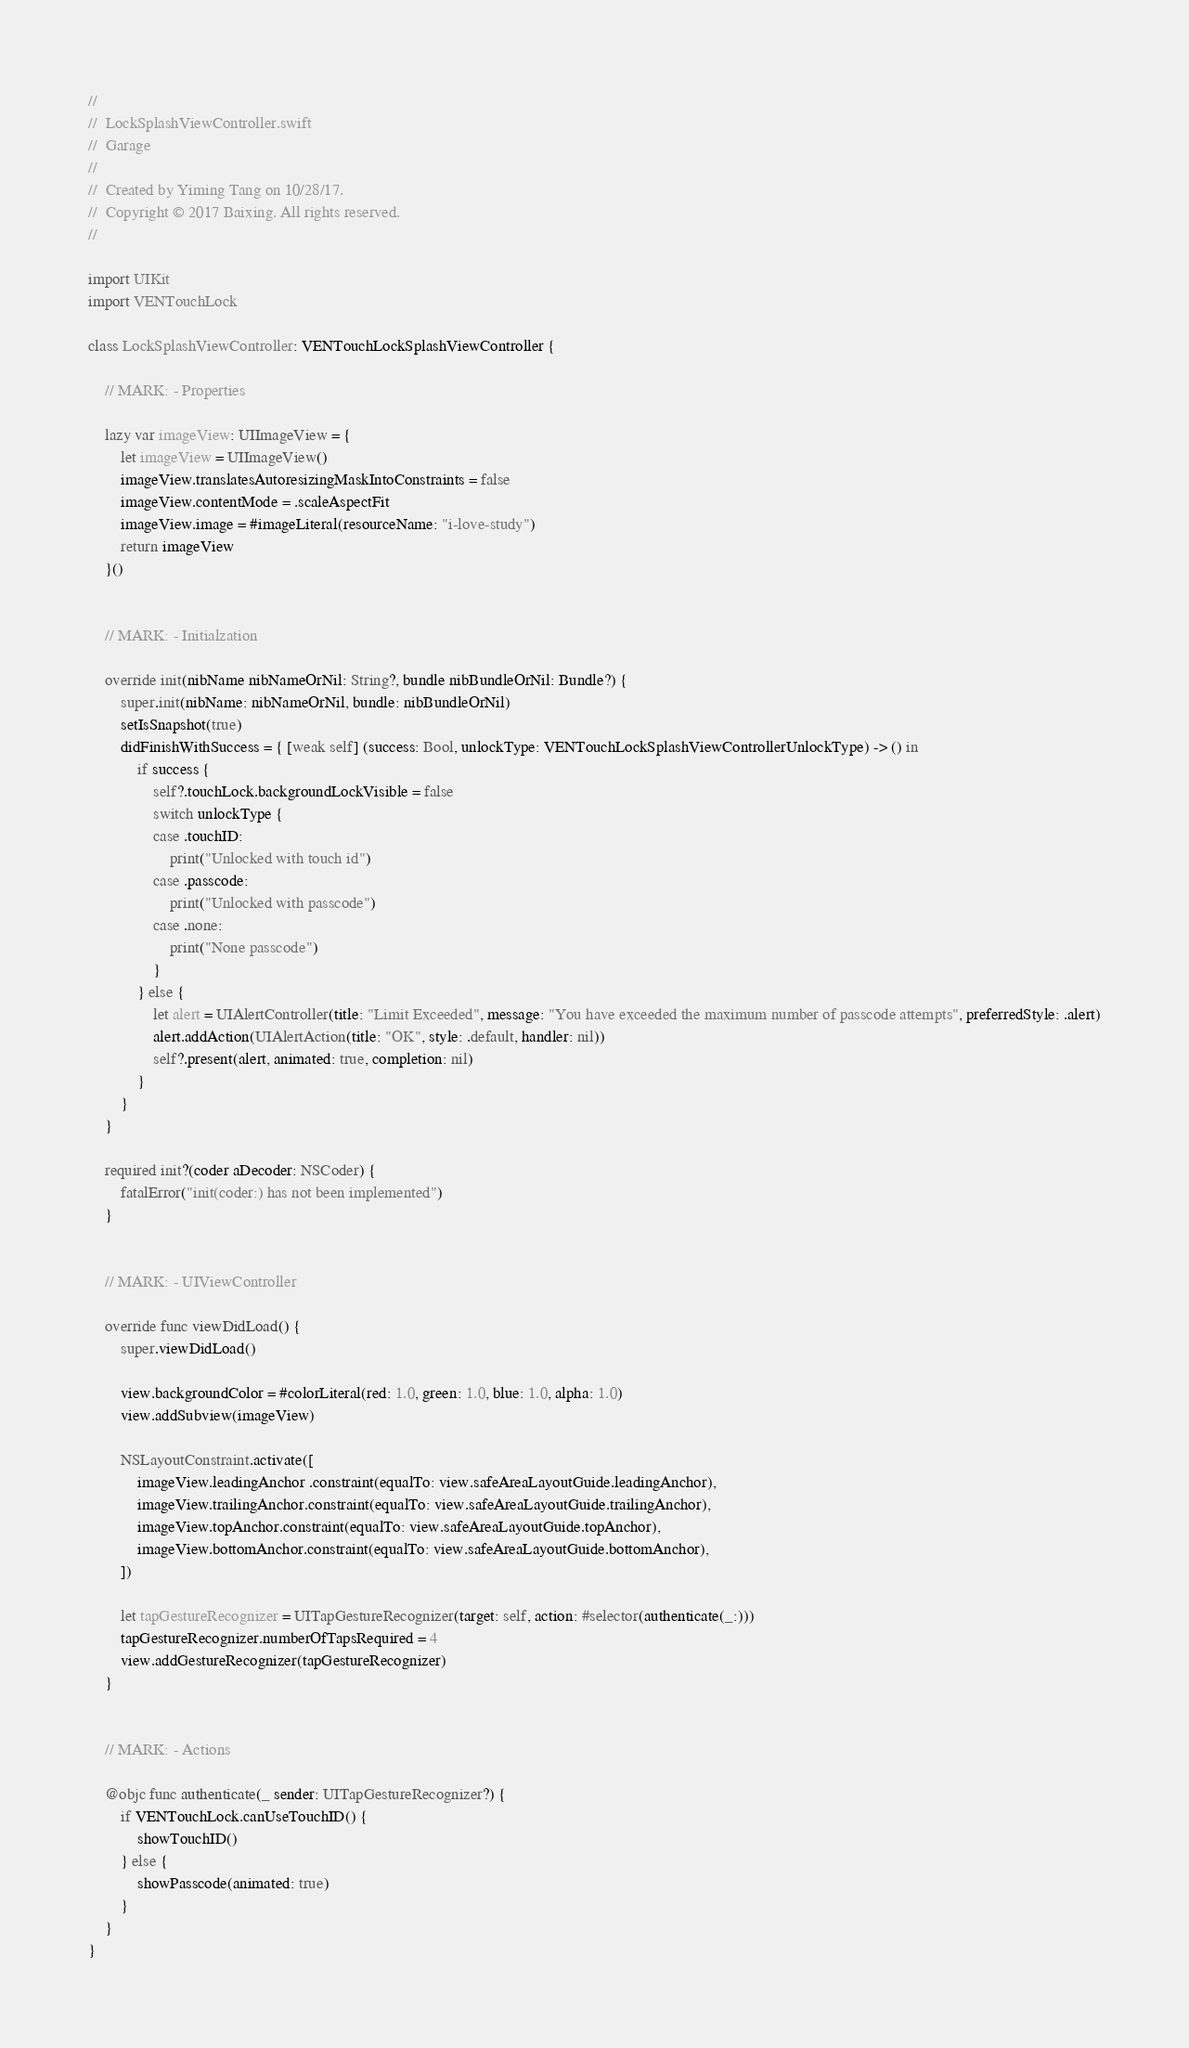<code> <loc_0><loc_0><loc_500><loc_500><_Swift_>//
//  LockSplashViewController.swift
//  Garage
//
//  Created by Yiming Tang on 10/28/17.
//  Copyright © 2017 Baixing. All rights reserved.
//

import UIKit
import VENTouchLock

class LockSplashViewController: VENTouchLockSplashViewController {

    // MARK: - Properties

    lazy var imageView: UIImageView = {
        let imageView = UIImageView()
        imageView.translatesAutoresizingMaskIntoConstraints = false
        imageView.contentMode = .scaleAspectFit
        imageView.image = #imageLiteral(resourceName: "i-love-study")
        return imageView
    }()


    // MARK: - Initialzation

    override init(nibName nibNameOrNil: String?, bundle nibBundleOrNil: Bundle?) {
        super.init(nibName: nibNameOrNil, bundle: nibBundleOrNil)
        setIsSnapshot(true)
        didFinishWithSuccess = { [weak self] (success: Bool, unlockType: VENTouchLockSplashViewControllerUnlockType) -> () in
            if success {
                self?.touchLock.backgroundLockVisible = false
                switch unlockType {
                case .touchID:
                    print("Unlocked with touch id")
                case .passcode:
                    print("Unlocked with passcode")
                case .none:
                    print("None passcode")
                }
            } else {
                let alert = UIAlertController(title: "Limit Exceeded", message: "You have exceeded the maximum number of passcode attempts", preferredStyle: .alert)
                alert.addAction(UIAlertAction(title: "OK", style: .default, handler: nil))
                self?.present(alert, animated: true, completion: nil)
            }
        }
    }

    required init?(coder aDecoder: NSCoder) {
        fatalError("init(coder:) has not been implemented")
    }


    // MARK: - UIViewController

    override func viewDidLoad() {
        super.viewDidLoad()

        view.backgroundColor = #colorLiteral(red: 1.0, green: 1.0, blue: 1.0, alpha: 1.0)
        view.addSubview(imageView)

        NSLayoutConstraint.activate([
            imageView.leadingAnchor .constraint(equalTo: view.safeAreaLayoutGuide.leadingAnchor),
            imageView.trailingAnchor.constraint(equalTo: view.safeAreaLayoutGuide.trailingAnchor),
            imageView.topAnchor.constraint(equalTo: view.safeAreaLayoutGuide.topAnchor),
            imageView.bottomAnchor.constraint(equalTo: view.safeAreaLayoutGuide.bottomAnchor),
        ])

        let tapGestureRecognizer = UITapGestureRecognizer(target: self, action: #selector(authenticate(_:)))
        tapGestureRecognizer.numberOfTapsRequired = 4
        view.addGestureRecognizer(tapGestureRecognizer)
    }


    // MARK: - Actions

    @objc func authenticate(_ sender: UITapGestureRecognizer?) {
        if VENTouchLock.canUseTouchID() {
            showTouchID()
        } else {
            showPasscode(animated: true)
        }
    }
}
</code> 